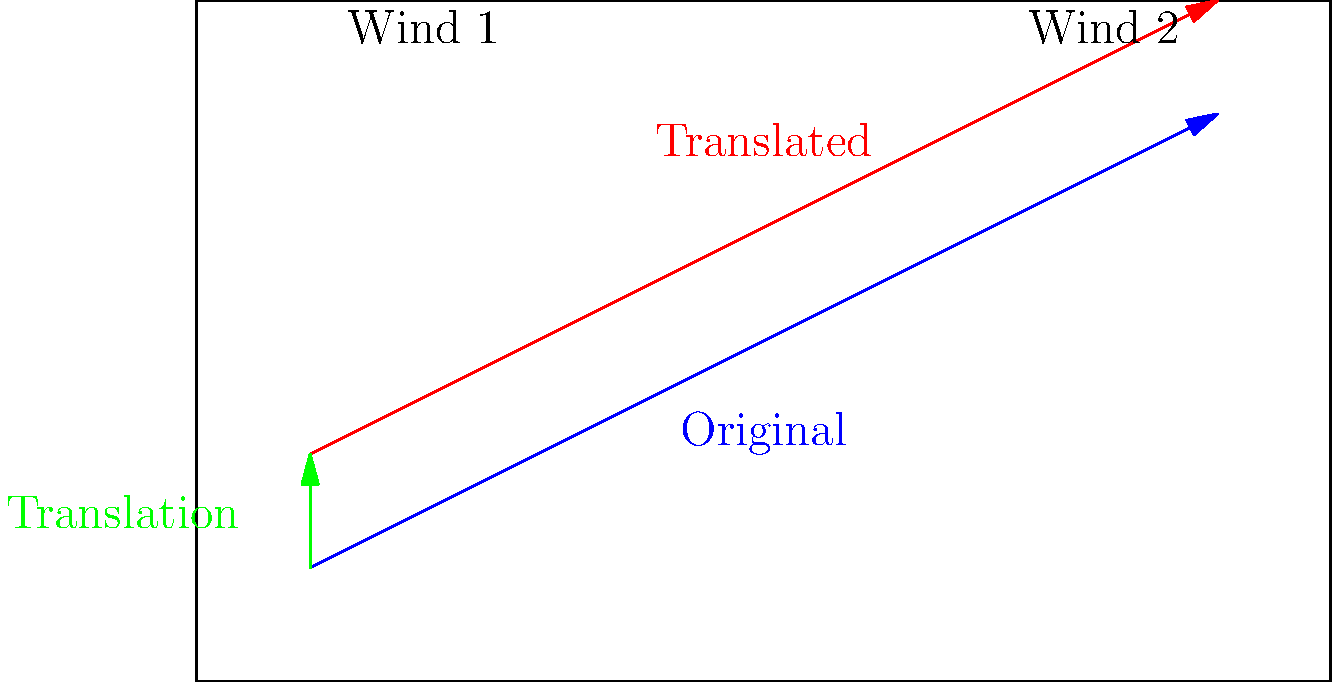A golfer hits a ball with an initial trajectory represented by the blue arrow on the course diagram. Due to a change in wind conditions, the ball's path is translated 1 unit upward, as shown by the red arrow. If the original trajectory can be described by the equation $y = \frac{1}{2}x + \frac{1}{2}$, what is the equation of the translated trajectory? To solve this problem, we'll follow these steps:

1) The original trajectory is given by the equation $y = \frac{1}{2}x + \frac{1}{2}$.

2) The translation is 1 unit upward. In transformational geometry, a vertical translation of $k$ units changes the equation from $y = f(x)$ to $y = f(x) + k$.

3) In this case, $k = 1$ (upward translation of 1 unit).

4) Therefore, we add 1 to the right side of the original equation:

   $y = (\frac{1}{2}x + \frac{1}{2}) + 1$

5) Simplify:
   $y = \frac{1}{2}x + \frac{1}{2} + 1$
   $y = \frac{1}{2}x + \frac{3}{2}$

Thus, the equation of the translated trajectory is $y = \frac{1}{2}x + \frac{3}{2}$.
Answer: $y = \frac{1}{2}x + \frac{3}{2}$ 